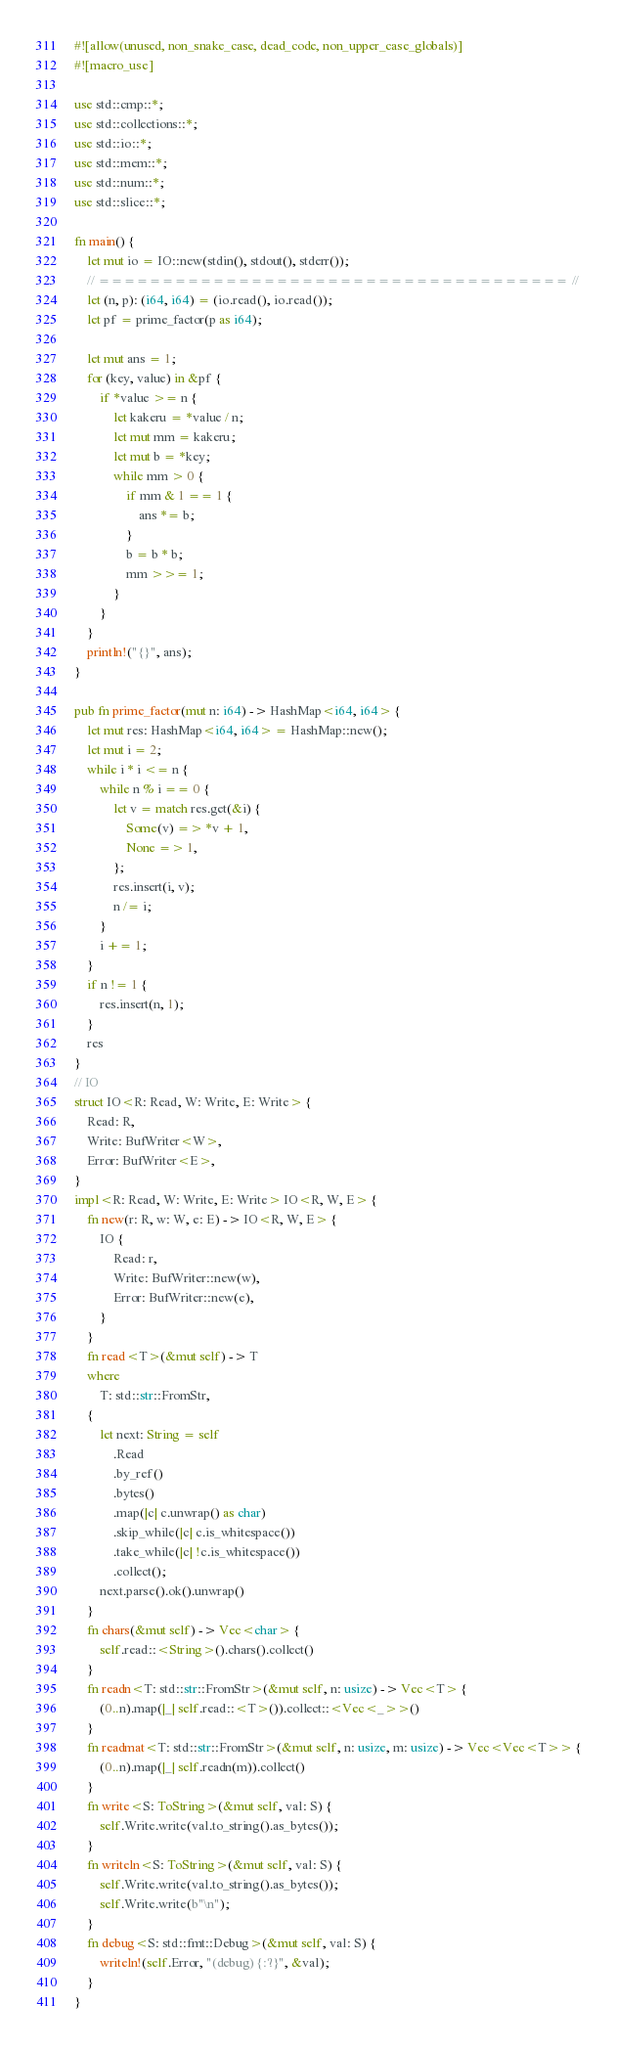Convert code to text. <code><loc_0><loc_0><loc_500><loc_500><_Rust_>#![allow(unused, non_snake_case, dead_code, non_upper_case_globals)]
#![macro_use]

use std::cmp::*;
use std::collections::*;
use std::io::*;
use std::mem::*;
use std::num::*;
use std::slice::*;

fn main() {
    let mut io = IO::new(stdin(), stdout(), stderr());
    // ===================================== //
    let (n, p): (i64, i64) = (io.read(), io.read());
    let pf = prime_factor(p as i64);

    let mut ans = 1;
    for (key, value) in &pf {
        if *value >= n {
            let kakeru = *value / n;
            let mut mm = kakeru;
            let mut b = *key;
            while mm > 0 {
                if mm & 1 == 1 {
                    ans *= b;
                }
                b = b * b;
                mm >>= 1;
            }
        }
    }
    println!("{}", ans);
}

pub fn prime_factor(mut n: i64) -> HashMap<i64, i64> {
    let mut res: HashMap<i64, i64> = HashMap::new();
    let mut i = 2;
    while i * i <= n {
        while n % i == 0 {
            let v = match res.get(&i) {
                Some(v) => *v + 1,
                None => 1,
            };
            res.insert(i, v);
            n /= i;
        }
        i += 1;
    }
    if n != 1 {
        res.insert(n, 1);
    }
    res
}
// IO
struct IO<R: Read, W: Write, E: Write> {
    Read: R,
    Write: BufWriter<W>,
    Error: BufWriter<E>,
}
impl<R: Read, W: Write, E: Write> IO<R, W, E> {
    fn new(r: R, w: W, e: E) -> IO<R, W, E> {
        IO {
            Read: r,
            Write: BufWriter::new(w),
            Error: BufWriter::new(e),
        }
    }
    fn read<T>(&mut self) -> T
    where
        T: std::str::FromStr,
    {
        let next: String = self
            .Read
            .by_ref()
            .bytes()
            .map(|c| c.unwrap() as char)
            .skip_while(|c| c.is_whitespace())
            .take_while(|c| !c.is_whitespace())
            .collect();
        next.parse().ok().unwrap()
    }
    fn chars(&mut self) -> Vec<char> {
        self.read::<String>().chars().collect()
    }
    fn readn<T: std::str::FromStr>(&mut self, n: usize) -> Vec<T> {
        (0..n).map(|_| self.read::<T>()).collect::<Vec<_>>()
    }
    fn readmat<T: std::str::FromStr>(&mut self, n: usize, m: usize) -> Vec<Vec<T>> {
        (0..n).map(|_| self.readn(m)).collect()
    }
    fn write<S: ToString>(&mut self, val: S) {
        self.Write.write(val.to_string().as_bytes());
    }
    fn writeln<S: ToString>(&mut self, val: S) {
        self.Write.write(val.to_string().as_bytes());
        self.Write.write(b"\n");
    }
    fn debug<S: std::fmt::Debug>(&mut self, val: S) {
        writeln!(self.Error, "(debug) {:?}", &val);
    }
}
</code> 